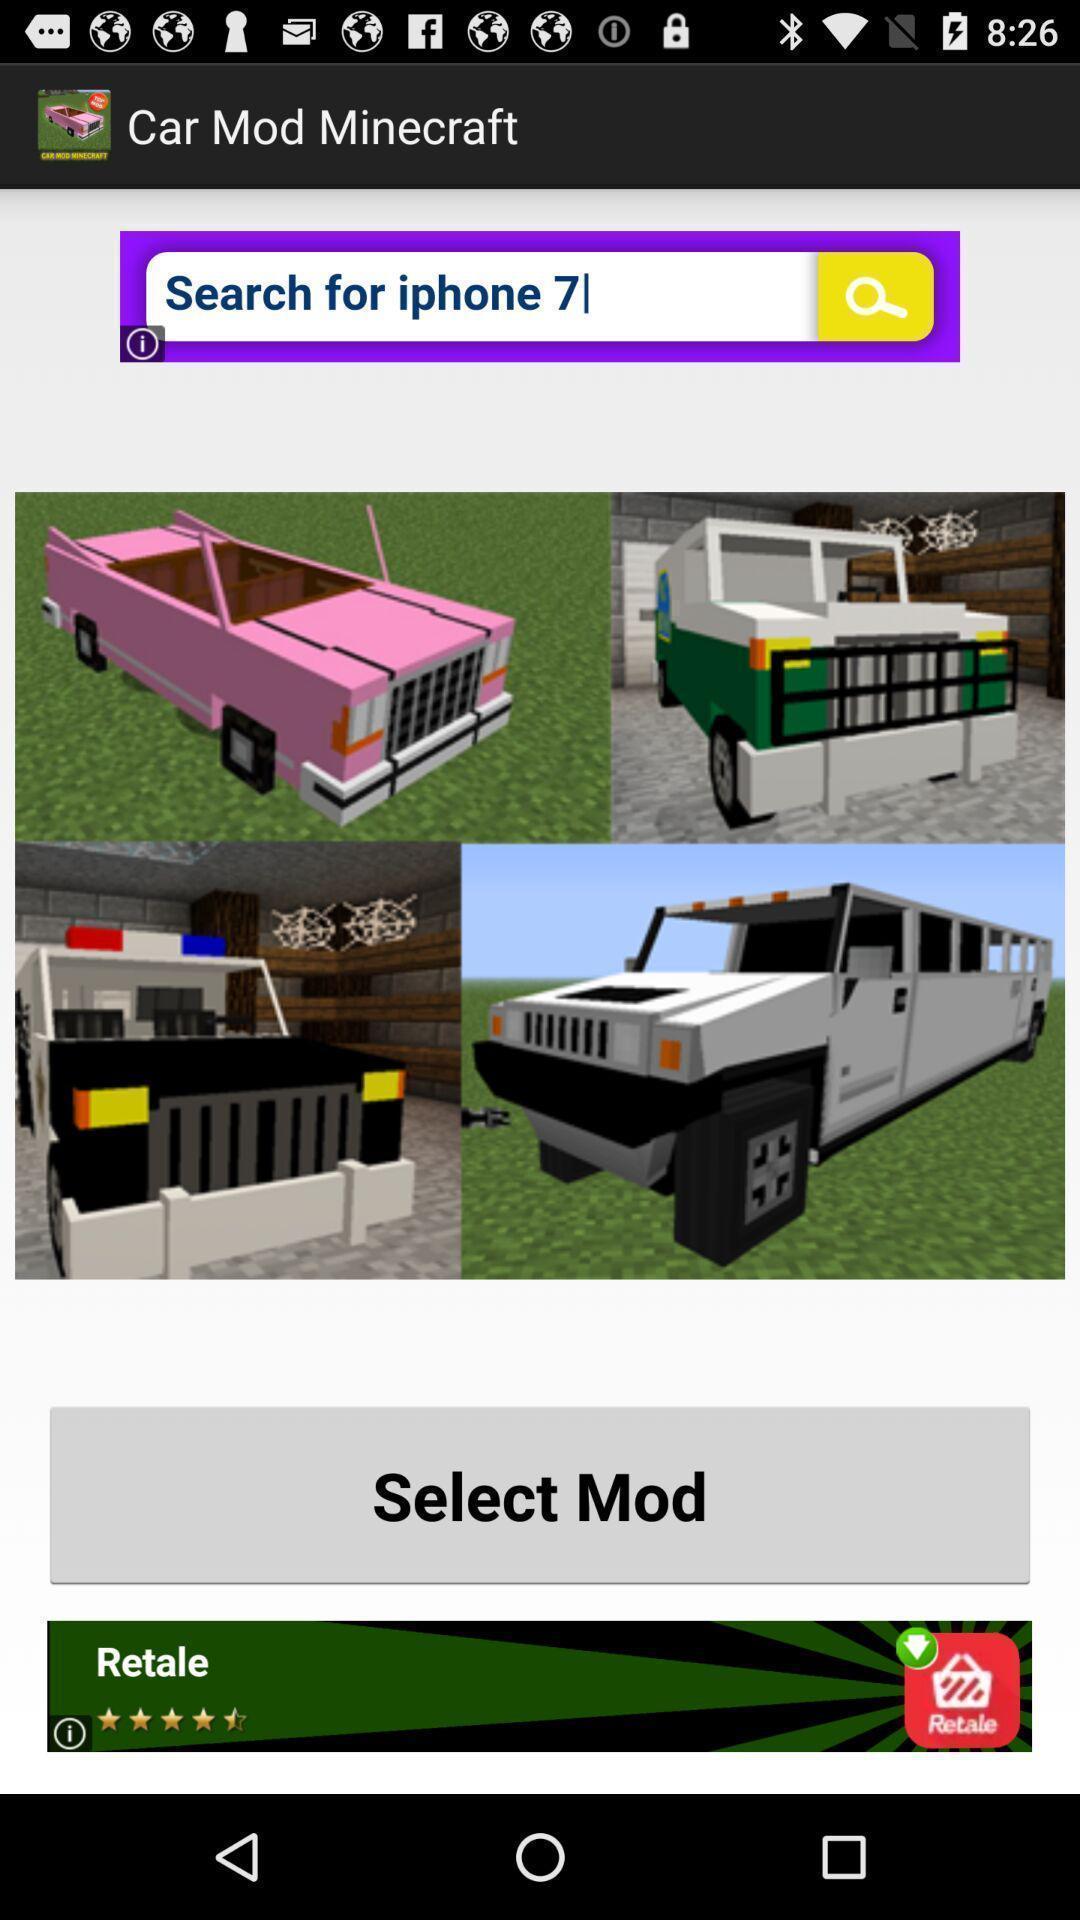Explain what's happening in this screen capture. Page with search bar and few images. 